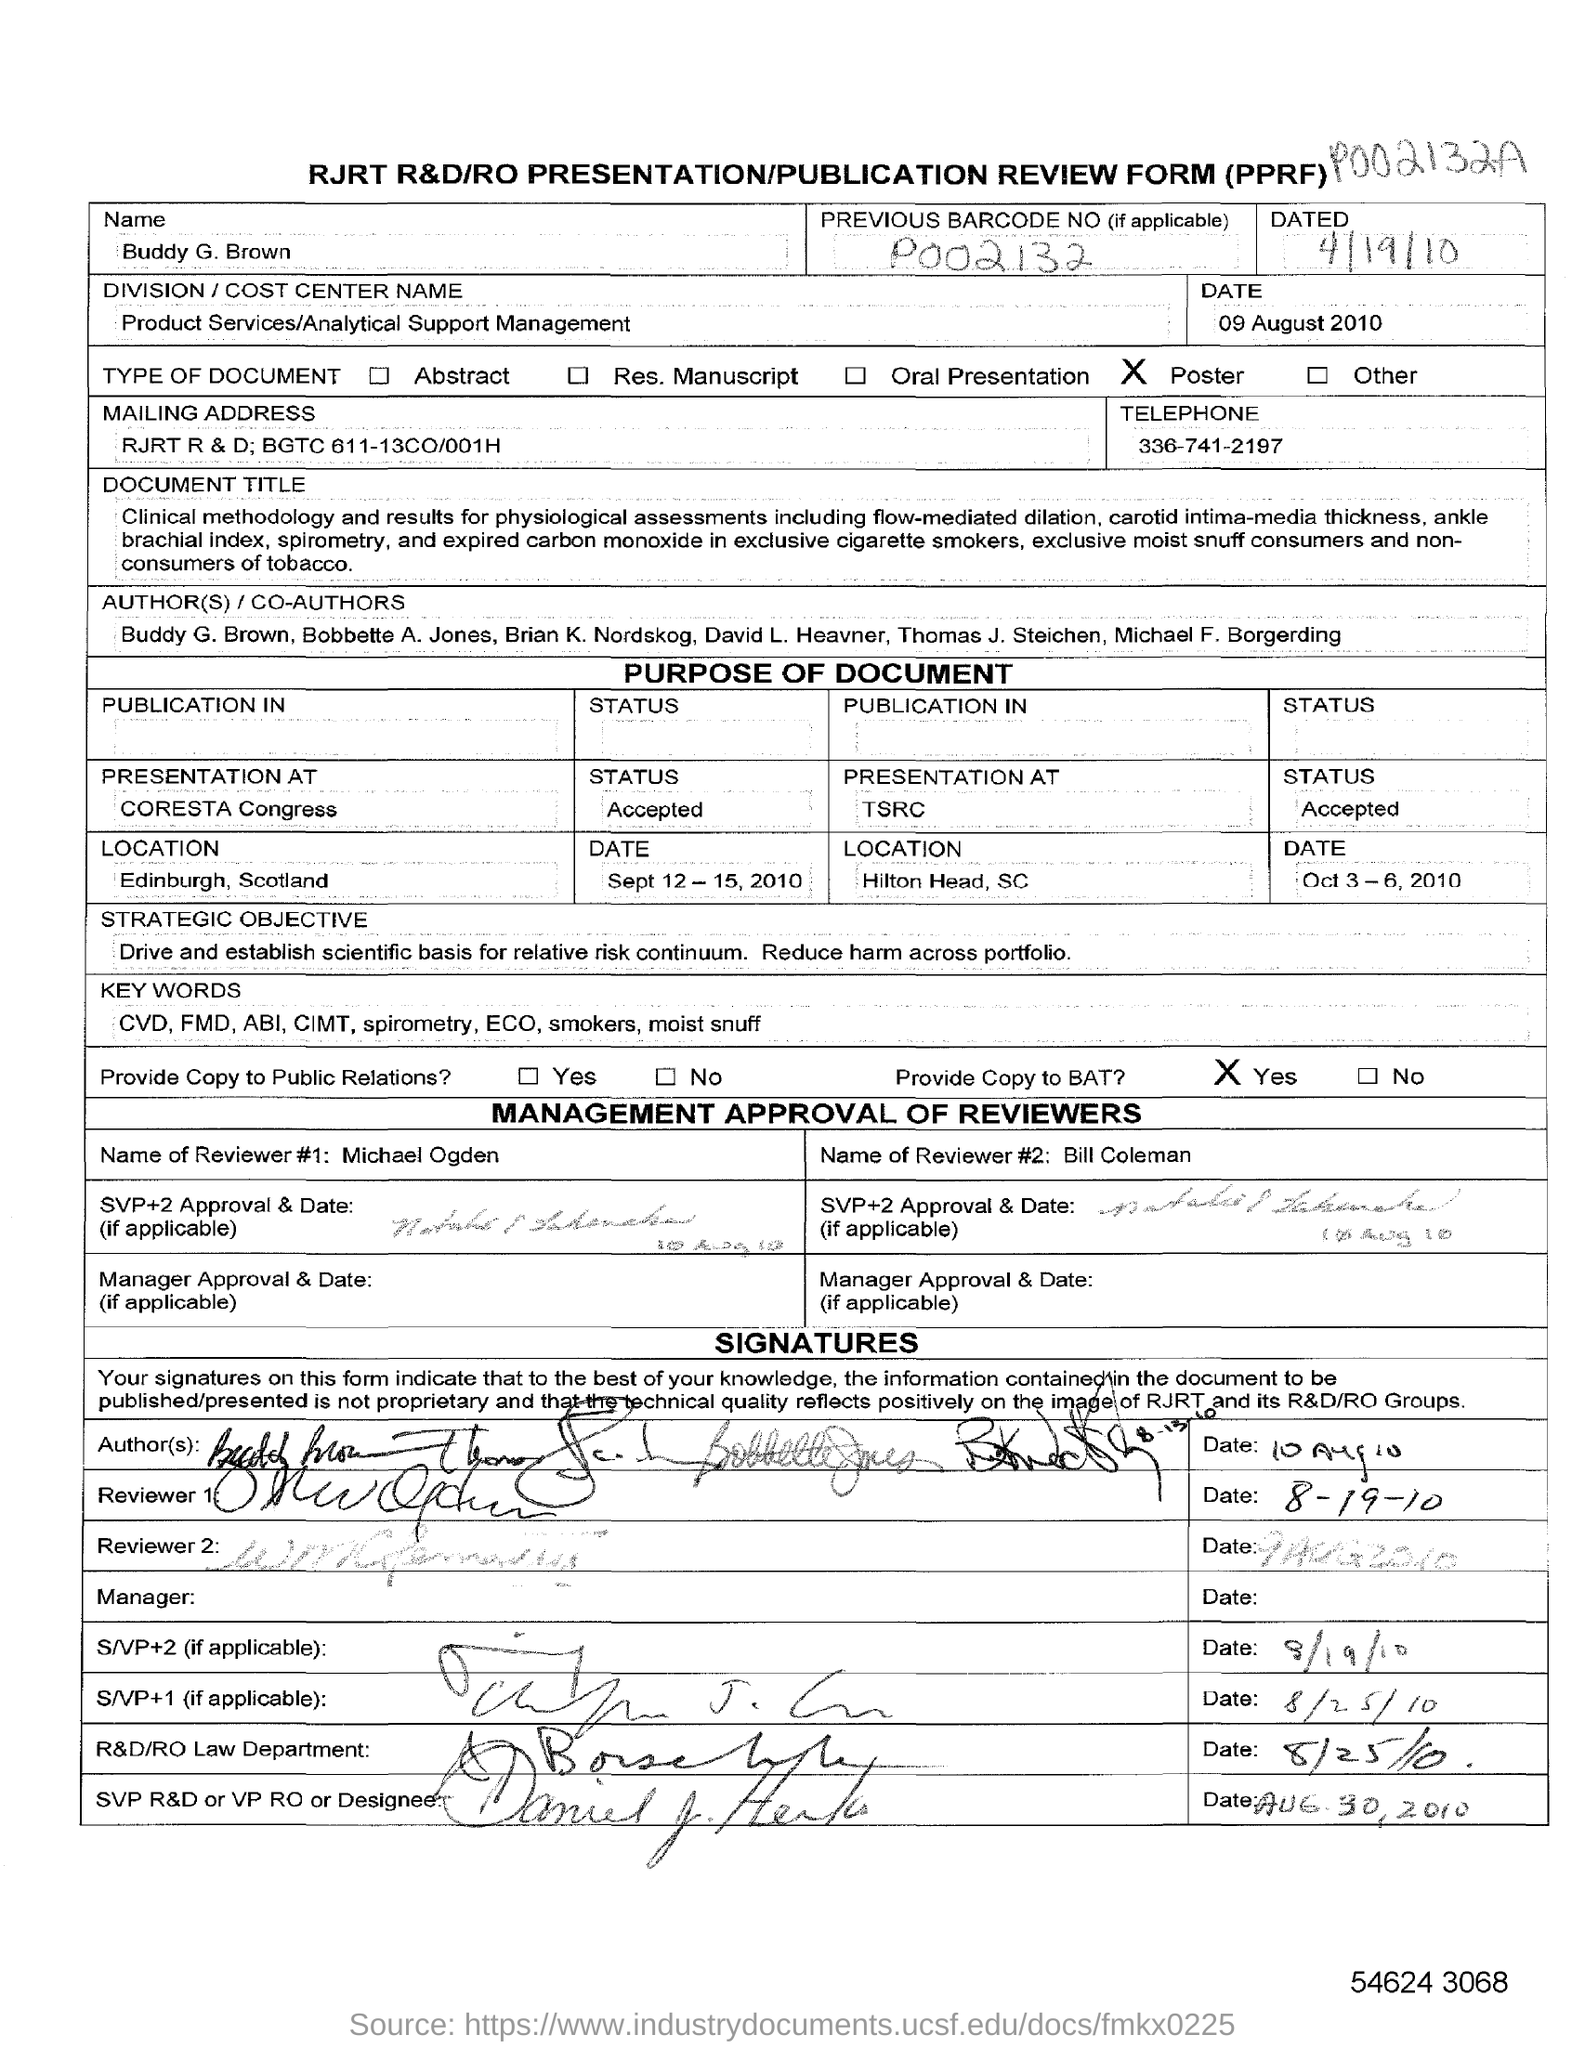Give some essential details in this illustration. The full form of PPRF is Presentation/Publication Review Form. The mailing address provided in the form is RJRT R & D; BGTC 611-13CO/001H. The division/cost center name provided in the form is Product Services/Analytical Support Management. The reviewer's name provided in the form is Michael Ogden. The previous barcode number provided in the form is P002132... 